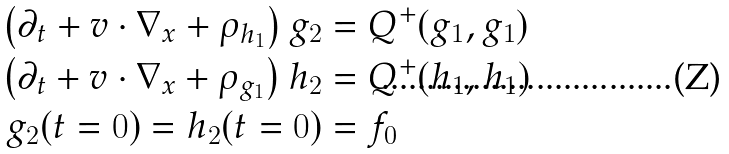<formula> <loc_0><loc_0><loc_500><loc_500>\left ( \partial _ { t } + v \cdot \nabla _ { x } + \rho _ { h _ { 1 } } \right ) g _ { 2 } & = Q ^ { + } ( g _ { 1 } , g _ { 1 } ) \\ \left ( \partial _ { t } + v \cdot \nabla _ { x } + \rho _ { g _ { 1 } } \right ) h _ { 2 } & = Q ^ { + } ( h _ { 1 } , h _ { 1 } ) \\ g _ { 2 } ( t = 0 ) = h _ { 2 } ( t = 0 ) & = f _ { 0 }</formula> 